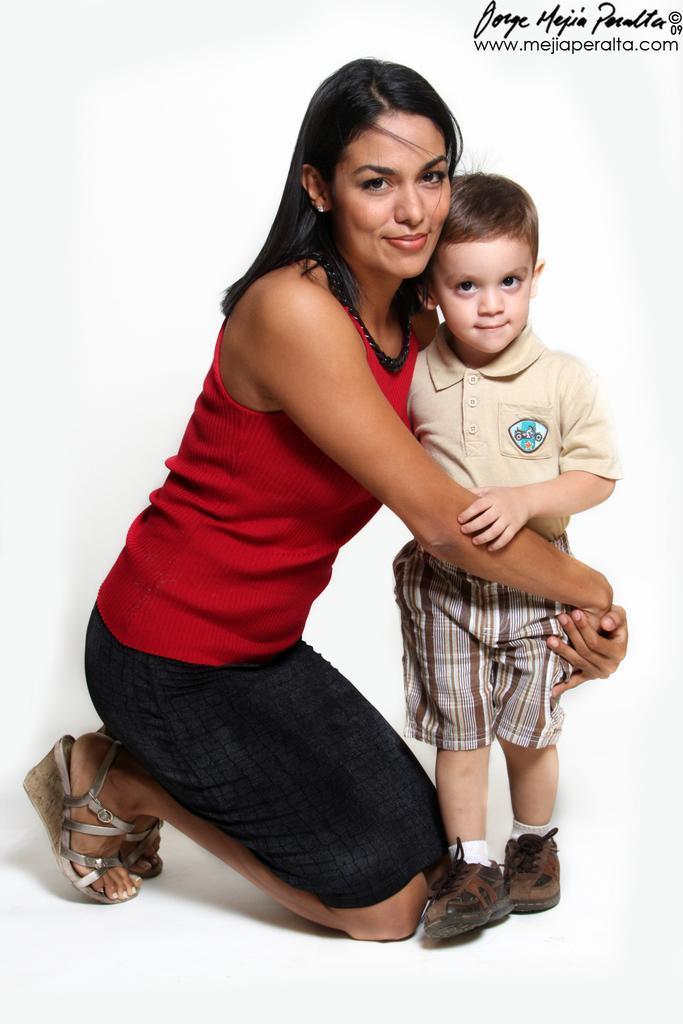In one or two sentences, can you explain what this image depicts? In this image we can see a woman and a child on the surface. In that we can see the woman sitting on her knees holding a child. 